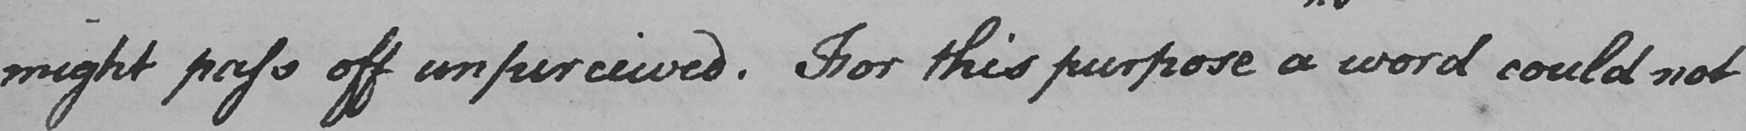Please provide the text content of this handwritten line. might pass off unperceived . For this purpose a word could not 